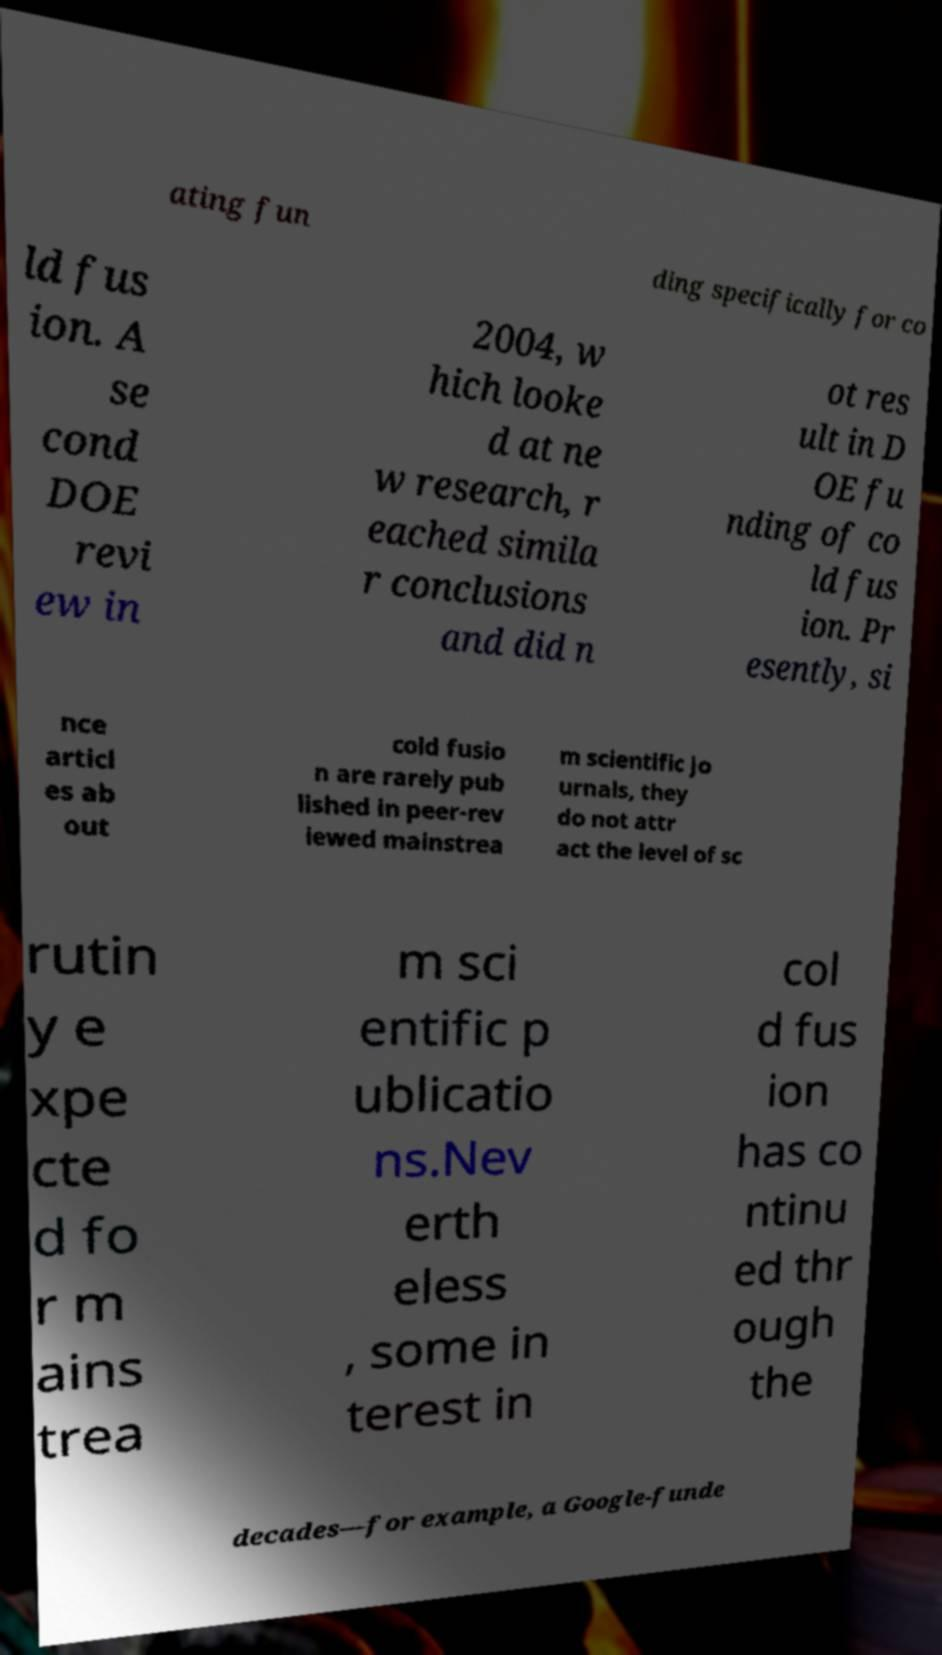Can you read and provide the text displayed in the image?This photo seems to have some interesting text. Can you extract and type it out for me? ating fun ding specifically for co ld fus ion. A se cond DOE revi ew in 2004, w hich looke d at ne w research, r eached simila r conclusions and did n ot res ult in D OE fu nding of co ld fus ion. Pr esently, si nce articl es ab out cold fusio n are rarely pub lished in peer-rev iewed mainstrea m scientific jo urnals, they do not attr act the level of sc rutin y e xpe cte d fo r m ains trea m sci entific p ublicatio ns.Nev erth eless , some in terest in col d fus ion has co ntinu ed thr ough the decades—for example, a Google-funde 